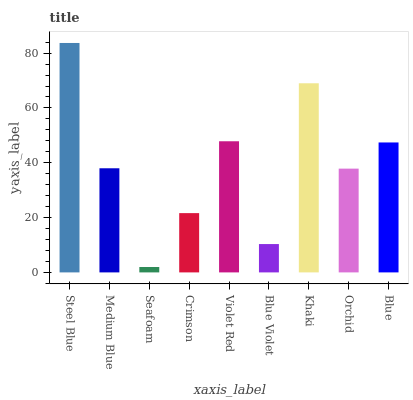Is Seafoam the minimum?
Answer yes or no. Yes. Is Steel Blue the maximum?
Answer yes or no. Yes. Is Medium Blue the minimum?
Answer yes or no. No. Is Medium Blue the maximum?
Answer yes or no. No. Is Steel Blue greater than Medium Blue?
Answer yes or no. Yes. Is Medium Blue less than Steel Blue?
Answer yes or no. Yes. Is Medium Blue greater than Steel Blue?
Answer yes or no. No. Is Steel Blue less than Medium Blue?
Answer yes or no. No. Is Medium Blue the high median?
Answer yes or no. Yes. Is Medium Blue the low median?
Answer yes or no. Yes. Is Steel Blue the high median?
Answer yes or no. No. Is Crimson the low median?
Answer yes or no. No. 